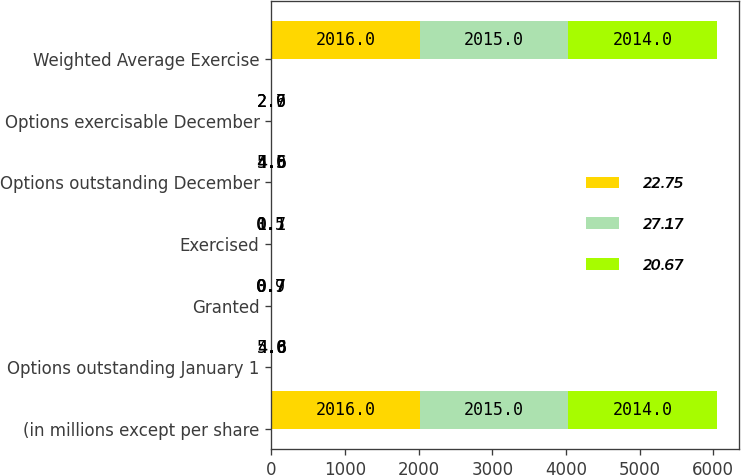Convert chart. <chart><loc_0><loc_0><loc_500><loc_500><stacked_bar_chart><ecel><fcel>(in millions except per share<fcel>Options outstanding January 1<fcel>Granted<fcel>Exercised<fcel>Options outstanding December<fcel>Options exercisable December<fcel>Weighted Average Exercise<nl><fcel>22.75<fcel>2016<fcel>5<fcel>0.7<fcel>1.1<fcel>4.5<fcel>2.7<fcel>2016<nl><fcel>27.17<fcel>2015<fcel>4.6<fcel>0.9<fcel>0.5<fcel>5<fcel>2.9<fcel>2015<nl><fcel>20.67<fcel>2014<fcel>4.8<fcel>0.7<fcel>0.7<fcel>4.6<fcel>2.6<fcel>2014<nl></chart> 